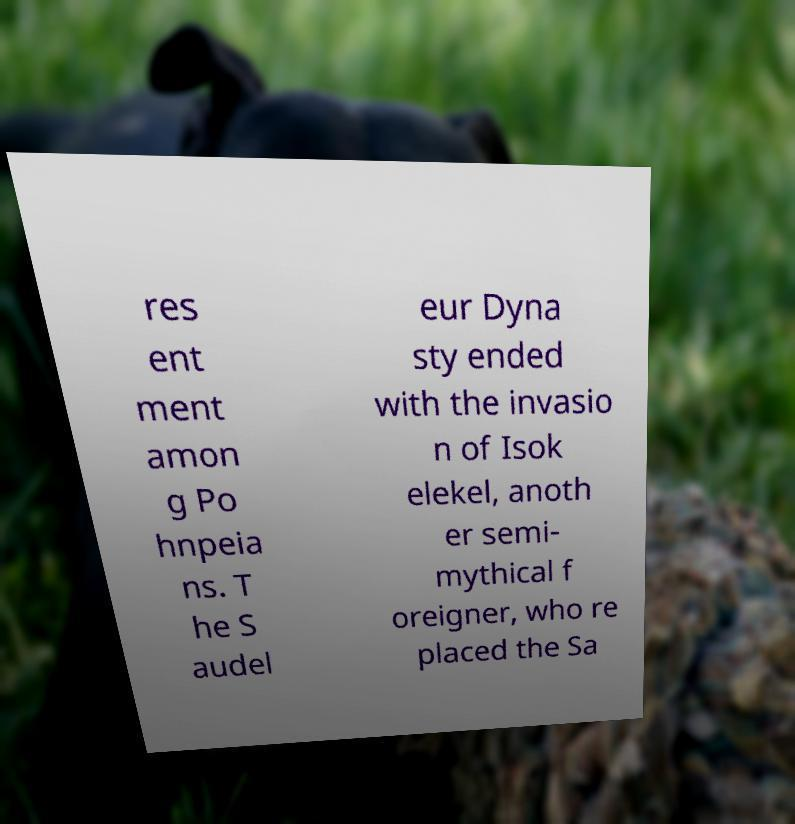Could you extract and type out the text from this image? res ent ment amon g Po hnpeia ns. T he S audel eur Dyna sty ended with the invasio n of Isok elekel, anoth er semi- mythical f oreigner, who re placed the Sa 